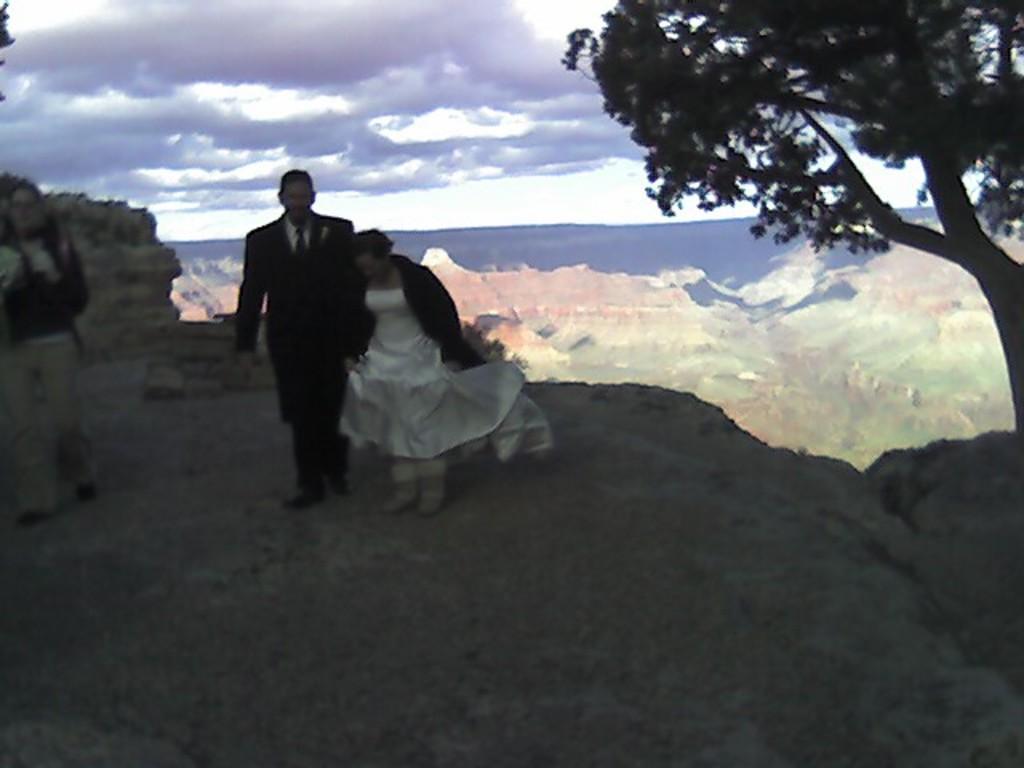Can you describe this image briefly? Here we can see three persons. There is a tree. In the background we can see sky with heavy clouds. 